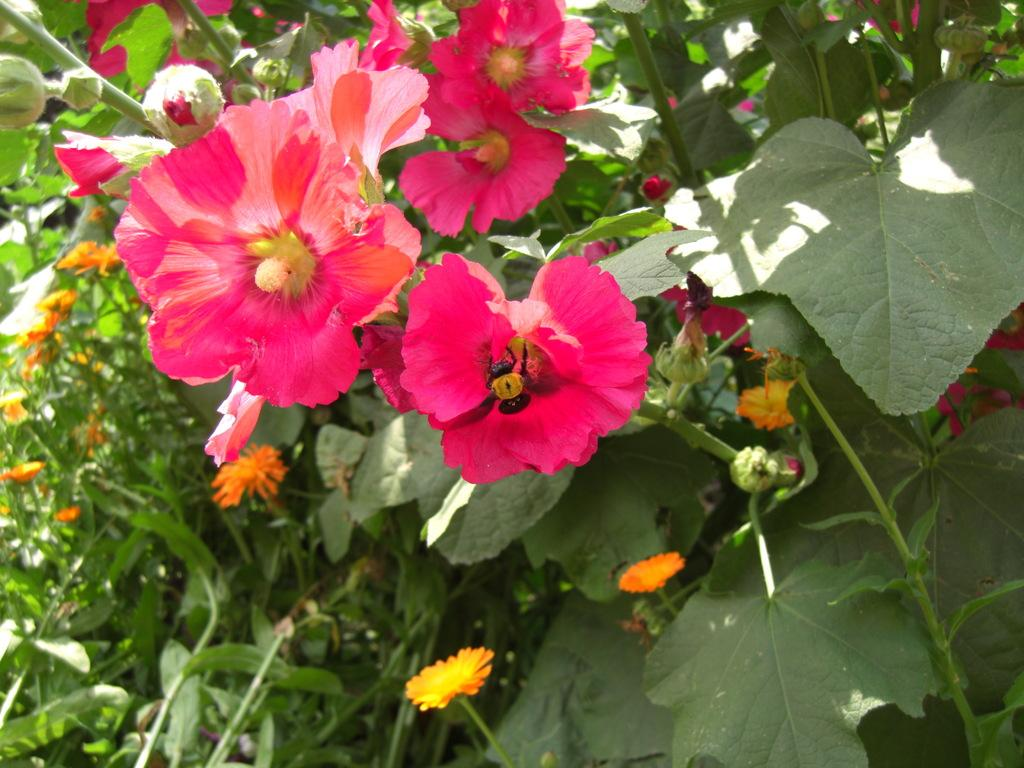What colors are the flowers in the image? There are pink and orange color flowers in the image. Are there any unopened flowers in the image? Yes, there are flower buds in the image. How many different types of plants are in the image? There are two different types of plants in the image. Who is the creator of the vest seen in the image? There is no vest present in the image, so it is not possible to determine the creator. 